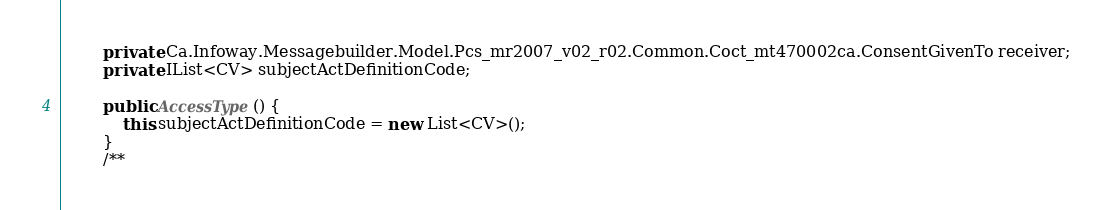Convert code to text. <code><loc_0><loc_0><loc_500><loc_500><_C#_>        private Ca.Infoway.Messagebuilder.Model.Pcs_mr2007_v02_r02.Common.Coct_mt470002ca.ConsentGivenTo receiver;
        private IList<CV> subjectActDefinitionCode;

        public AccessType() {
            this.subjectActDefinitionCode = new List<CV>();
        }
        /**</code> 